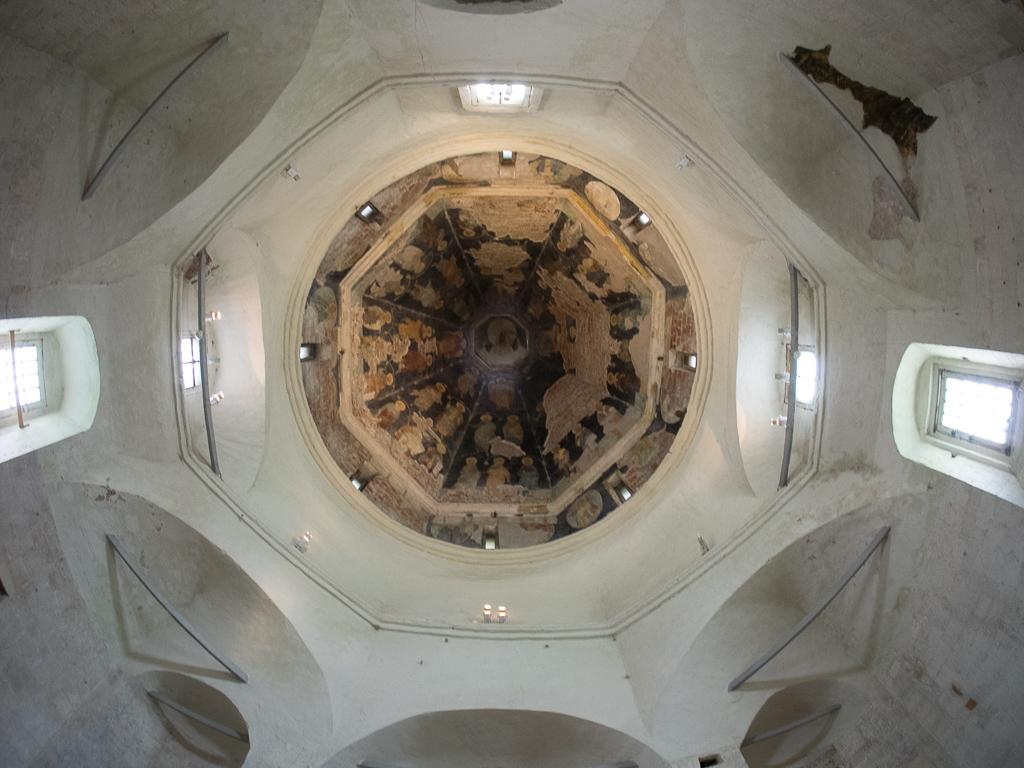What part of the building is visible in the image? The image shows the ceiling of a building. From where was the image captured? The image is captured from the ground. How many windows are visible on either side of the building? There are two windows on either side of the building. What type of flesh can be seen on the ceiling in the image? There is no flesh visible in the image; it shows the ceiling of a building. 